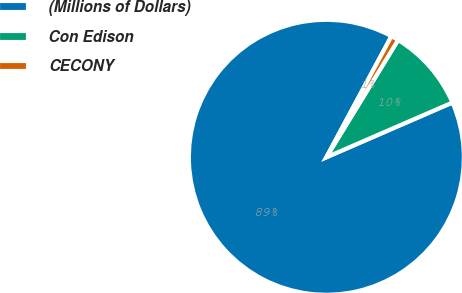<chart> <loc_0><loc_0><loc_500><loc_500><pie_chart><fcel>(Millions of Dollars)<fcel>Con Edison<fcel>CECONY<nl><fcel>89.38%<fcel>9.74%<fcel>0.89%<nl></chart> 